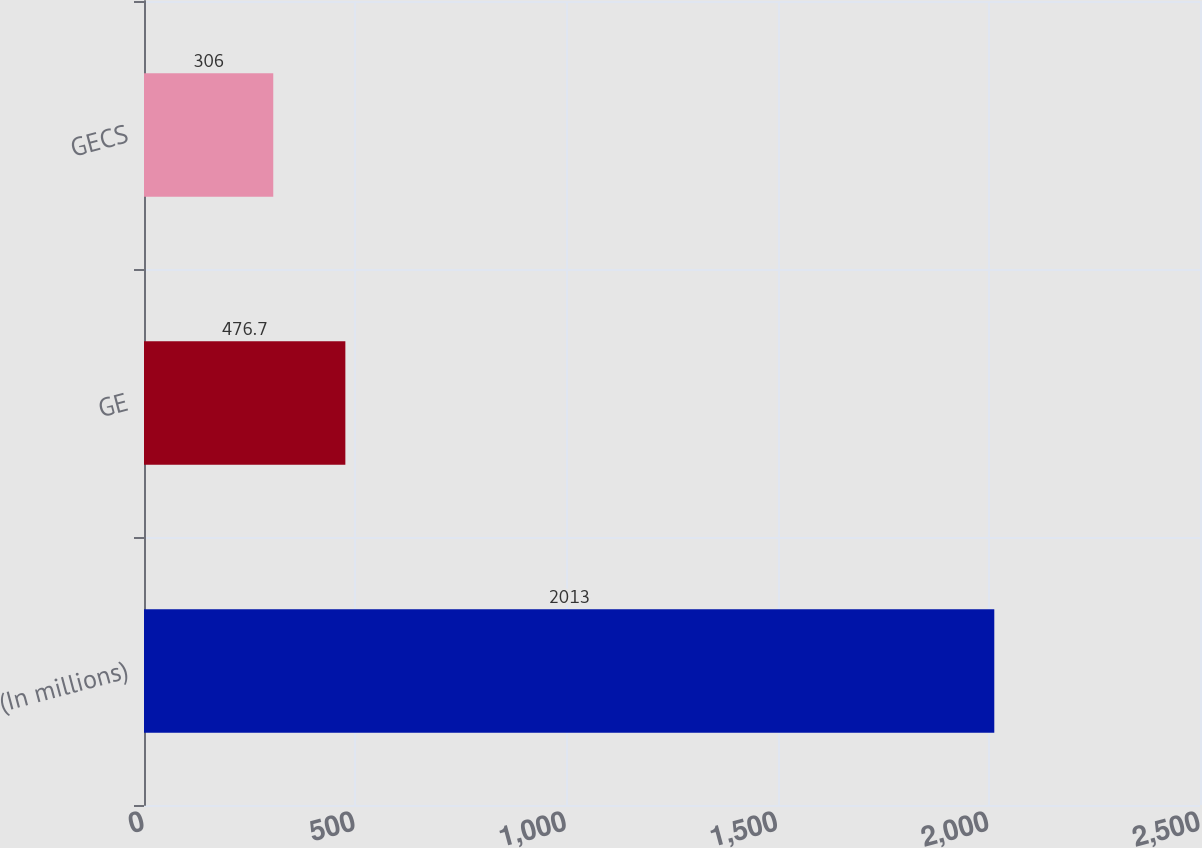<chart> <loc_0><loc_0><loc_500><loc_500><bar_chart><fcel>(In millions)<fcel>GE<fcel>GECS<nl><fcel>2013<fcel>476.7<fcel>306<nl></chart> 